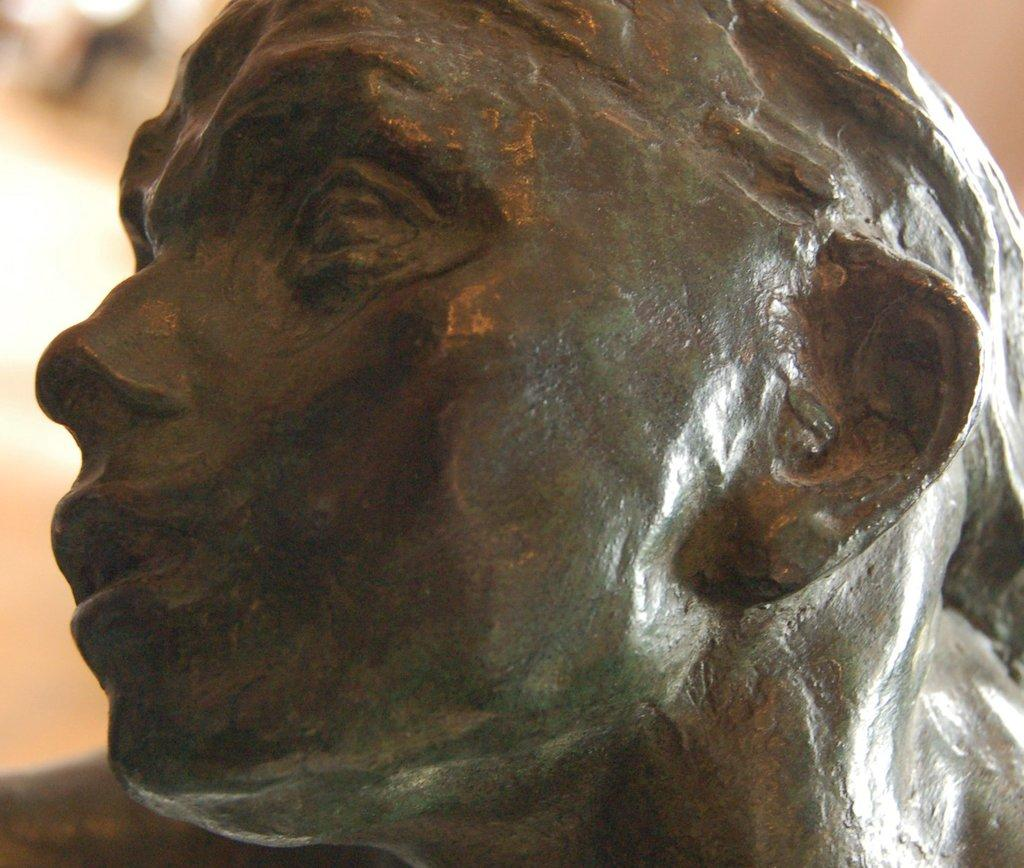What is the main subject of the image? There is a sculpture of a person's head in the image. Can you describe the sculpture in more detail? Unfortunately, the image is blurry in the background, so it's difficult to provide more details about the sculpture. What type of map is visible in the image? There is no map present in the image; it only features a sculpture of a person's head. 